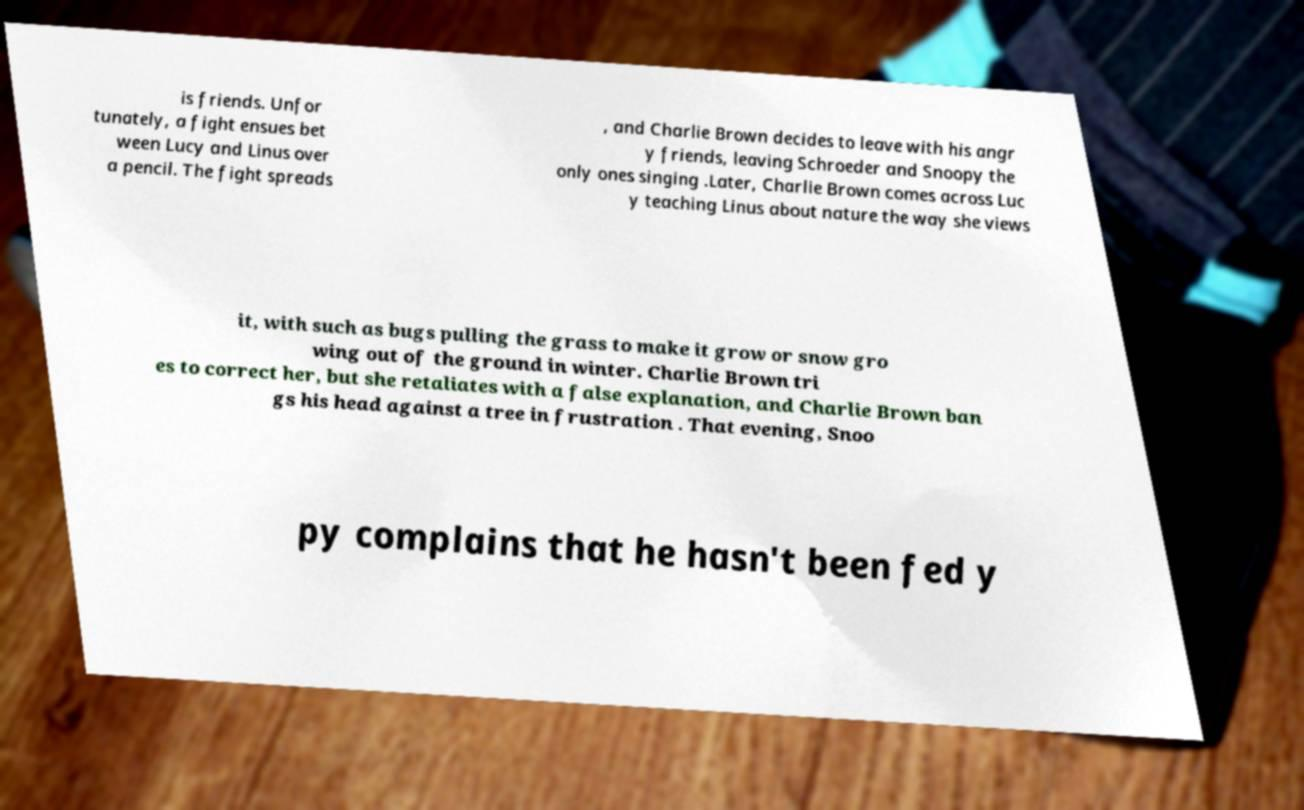What messages or text are displayed in this image? I need them in a readable, typed format. is friends. Unfor tunately, a fight ensues bet ween Lucy and Linus over a pencil. The fight spreads , and Charlie Brown decides to leave with his angr y friends, leaving Schroeder and Snoopy the only ones singing .Later, Charlie Brown comes across Luc y teaching Linus about nature the way she views it, with such as bugs pulling the grass to make it grow or snow gro wing out of the ground in winter. Charlie Brown tri es to correct her, but she retaliates with a false explanation, and Charlie Brown ban gs his head against a tree in frustration . That evening, Snoo py complains that he hasn't been fed y 